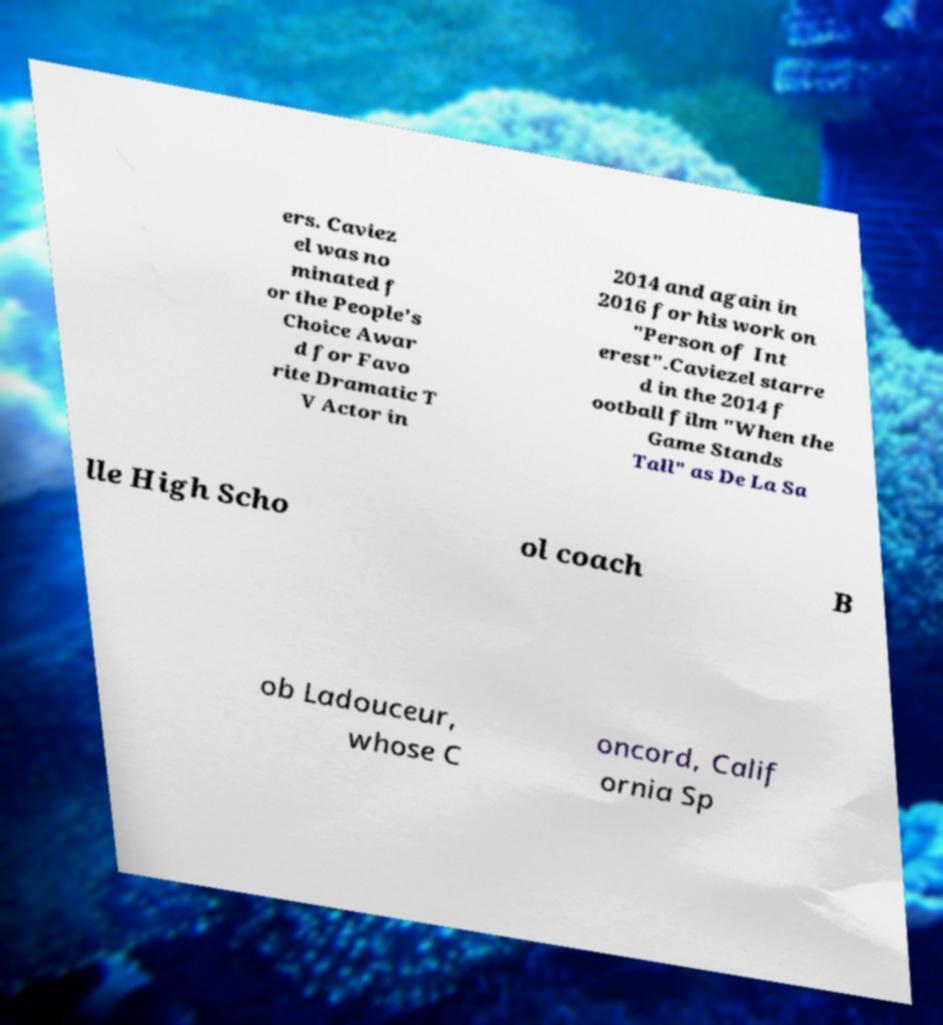Can you read and provide the text displayed in the image?This photo seems to have some interesting text. Can you extract and type it out for me? ers. Caviez el was no minated f or the People's Choice Awar d for Favo rite Dramatic T V Actor in 2014 and again in 2016 for his work on "Person of Int erest".Caviezel starre d in the 2014 f ootball film "When the Game Stands Tall" as De La Sa lle High Scho ol coach B ob Ladouceur, whose C oncord, Calif ornia Sp 